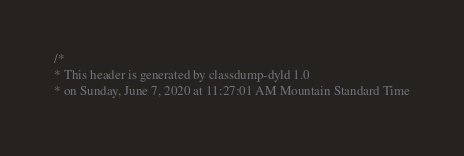<code> <loc_0><loc_0><loc_500><loc_500><_C_>/*
* This header is generated by classdump-dyld 1.0
* on Sunday, June 7, 2020 at 11:27:01 AM Mountain Standard Time</code> 